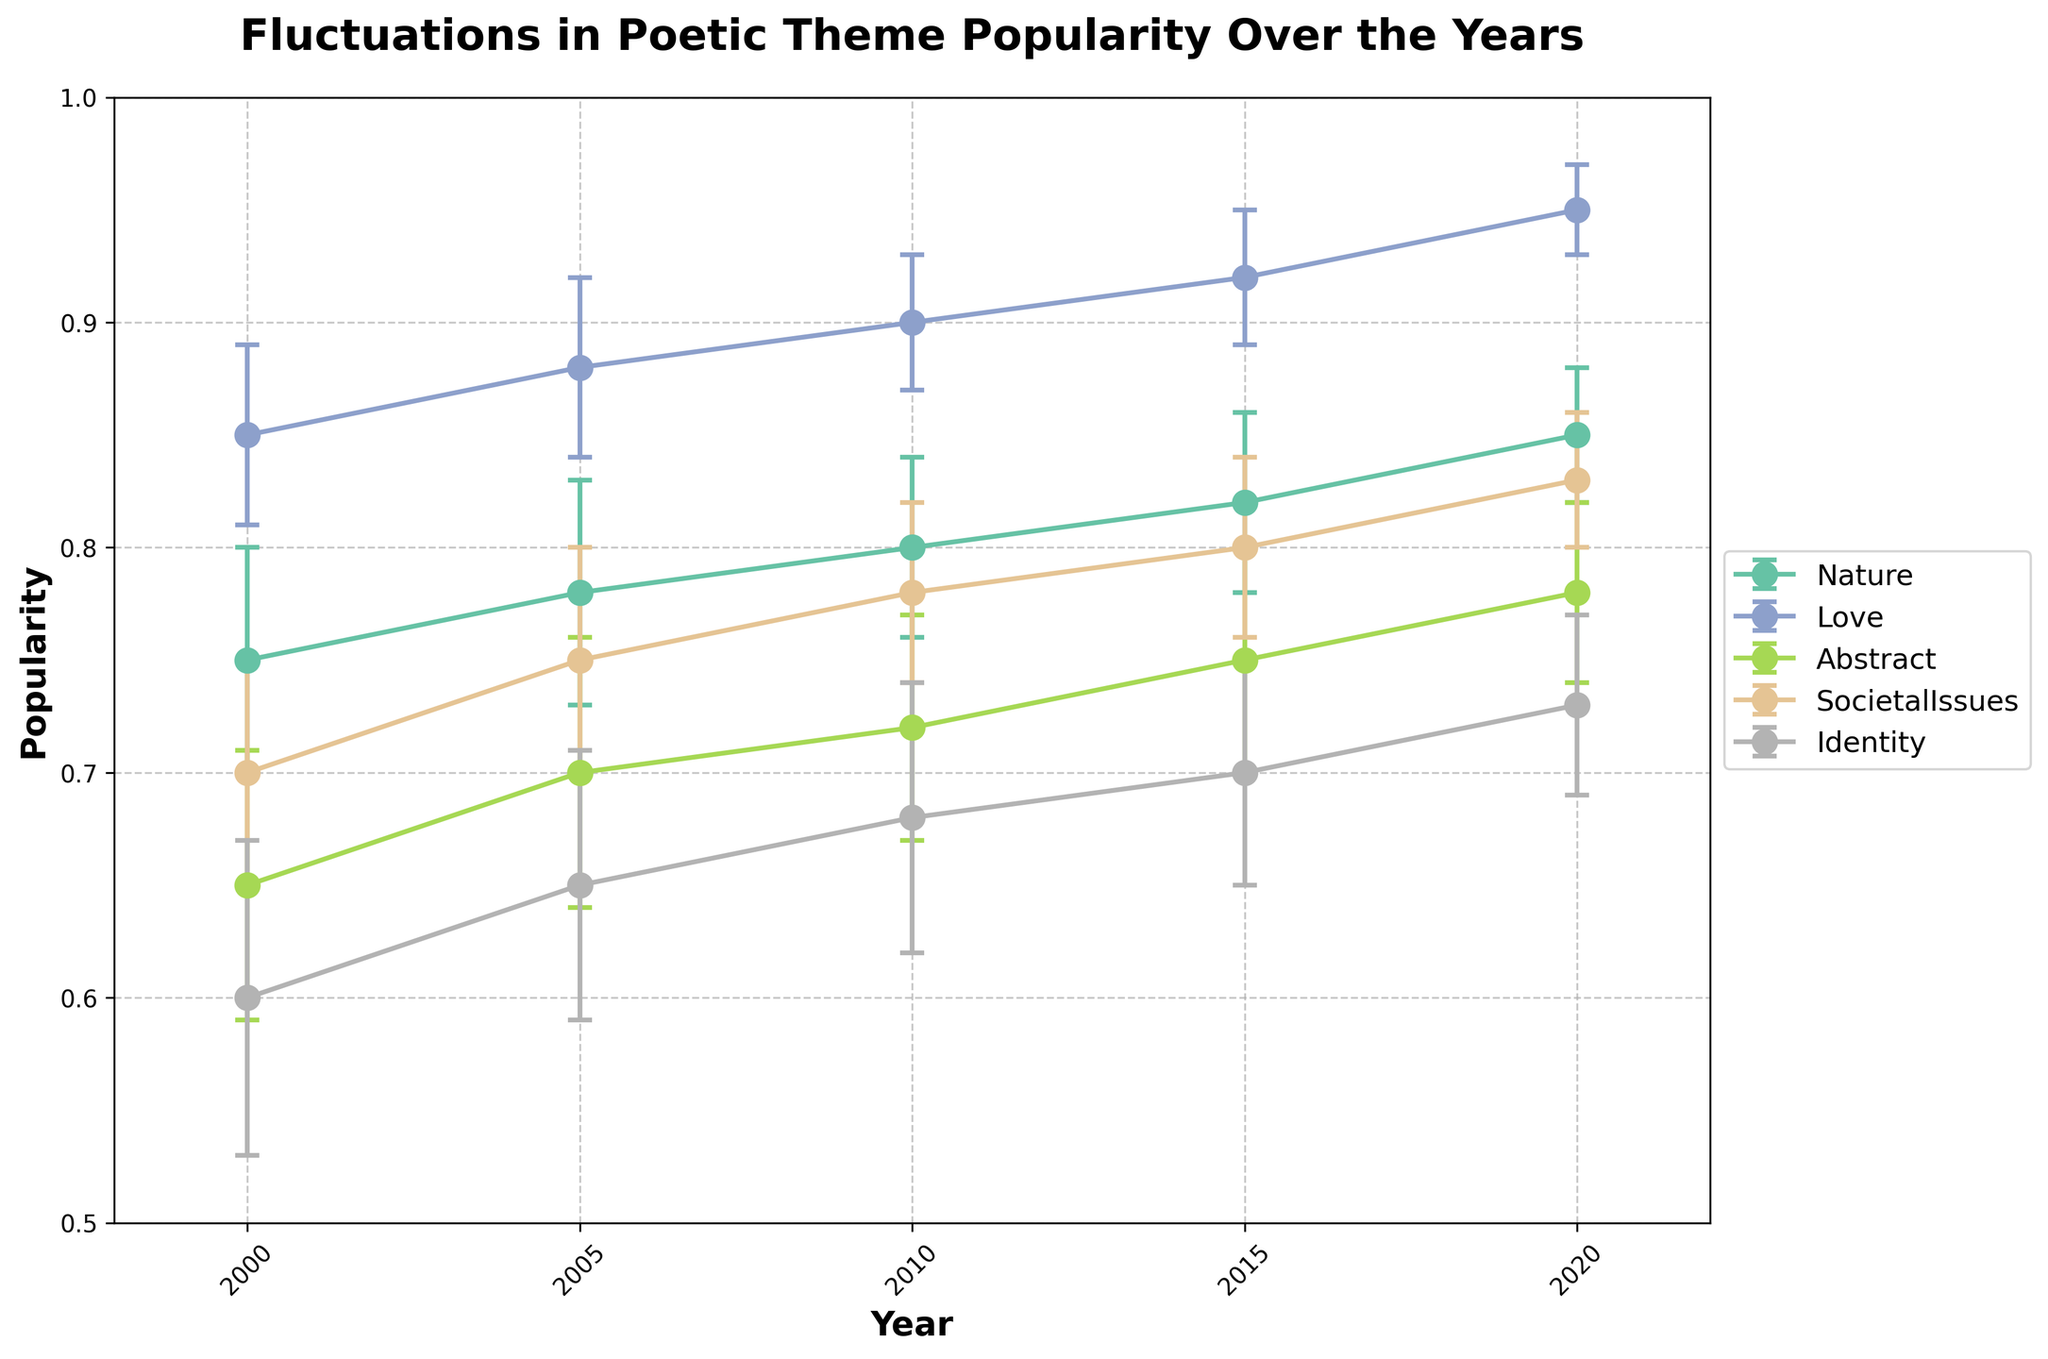What is the title of the plot? The title is displayed at the top of the plot. It reads "Fluctuations in Poetic Theme Popularity Over the Years".
Answer: Fluctuations in Poetic Theme Popularity Over the Years Which year does 'Nature' have the highest popularity? Look for the 'Nature' data points and identify the year with the highest popularity value. The year with the highest popularity for 'Nature' is 2020.
Answer: 2020 What is the lowest popularity value for the 'Identity' theme? Identify the 'Identity' theme data points and find the minimum value among them. The lowest popularity for 'Identity' is 0.60 in the year 2000.
Answer: 0.60 Comparing the 'Love' and 'Abstract' themes, which one had higher popularity in 2015? Locate the popularity values for 'Love' and 'Abstract' in 2015. 'Love' has a popularity of 0.92, while 'Abstract' has 0.75. Therefore, 'Love' is higher.
Answer: Love What is the average popularity of the 'SocietalIssues' theme across all years? Sum the popularity values for 'SocietalIssues' over all years, then divide by the number of years (5). (0.70 + 0.75 + 0.78 + 0.80 + 0.83) / 5 = 3.86 / 5
Answer: 0.772 What is the change in popularity of the 'Nature' theme from 2000 to 2020? Subtract the 2000 popularity value from the 2020 popularity value for the 'Nature' theme. 0.85 - 0.75 = 0.10
Answer: 0.10 How do the error bars for the 'Love' theme in 2010 compare to other years? Examine the height of the error bars for 'Love' in 2010 and compare them visually to the error bars for 'Love' in other years. The error bars in 2010 are shorter, indicating less uncertainty.
Answer: Shorter Which theme shows the highest popularity in 2020? Look at the popularity values for all themes in 2020 and identify the highest one. 'Love' has the highest value at 0.95.
Answer: Love Which theme shows the most consistent popularity (smallest fluctuation) across the years? Compare the error bars and changes in popularity for each theme across the years. 'Love' has the smallest fluctuations and consistent upward trend.
Answer: Love 